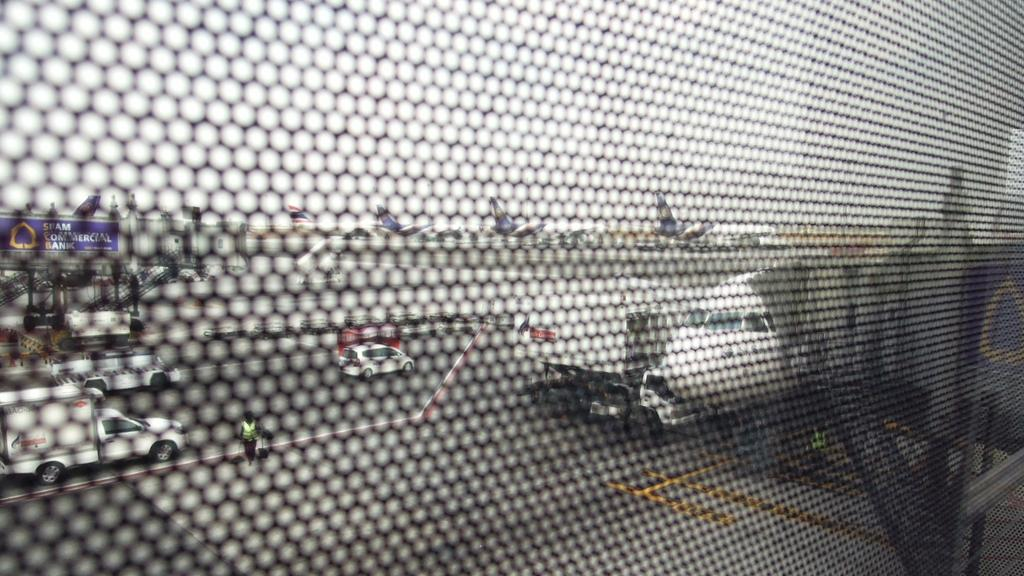What is located in the foreground of the image? There is a net in the foreground of the image. What can be seen in the background of the image? There are aeroplanes and cars in the background of the image. What type of books can be found in the library depicted in the image? There is no library present in the image; it features a net in the foreground and aeroplanes and cars in the background. 